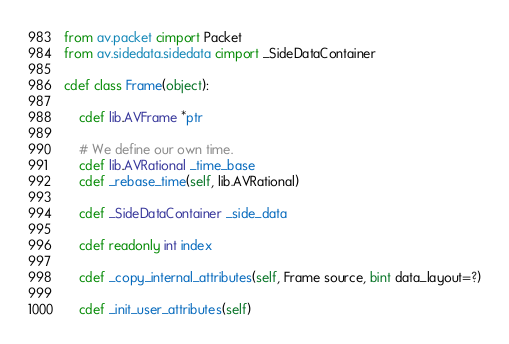Convert code to text. <code><loc_0><loc_0><loc_500><loc_500><_Cython_>
from av.packet cimport Packet
from av.sidedata.sidedata cimport _SideDataContainer

cdef class Frame(object):

    cdef lib.AVFrame *ptr

    # We define our own time.
    cdef lib.AVRational _time_base
    cdef _rebase_time(self, lib.AVRational)

    cdef _SideDataContainer _side_data

    cdef readonly int index

    cdef _copy_internal_attributes(self, Frame source, bint data_layout=?)

    cdef _init_user_attributes(self)
</code> 